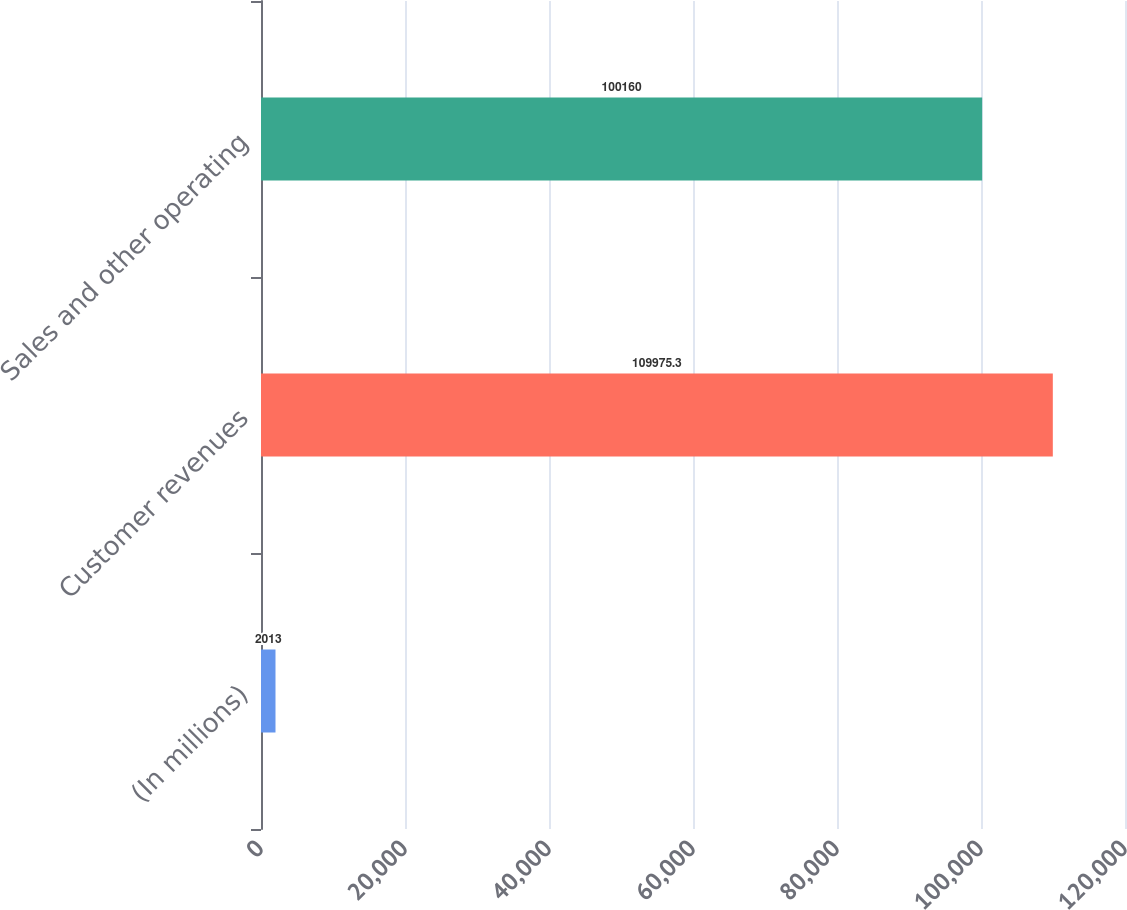Convert chart to OTSL. <chart><loc_0><loc_0><loc_500><loc_500><bar_chart><fcel>(In millions)<fcel>Customer revenues<fcel>Sales and other operating<nl><fcel>2013<fcel>109975<fcel>100160<nl></chart> 